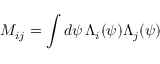<formula> <loc_0><loc_0><loc_500><loc_500>M _ { i j } = \int d \psi \, \Lambda _ { i } ( \psi ) \Lambda _ { j } ( \psi )</formula> 